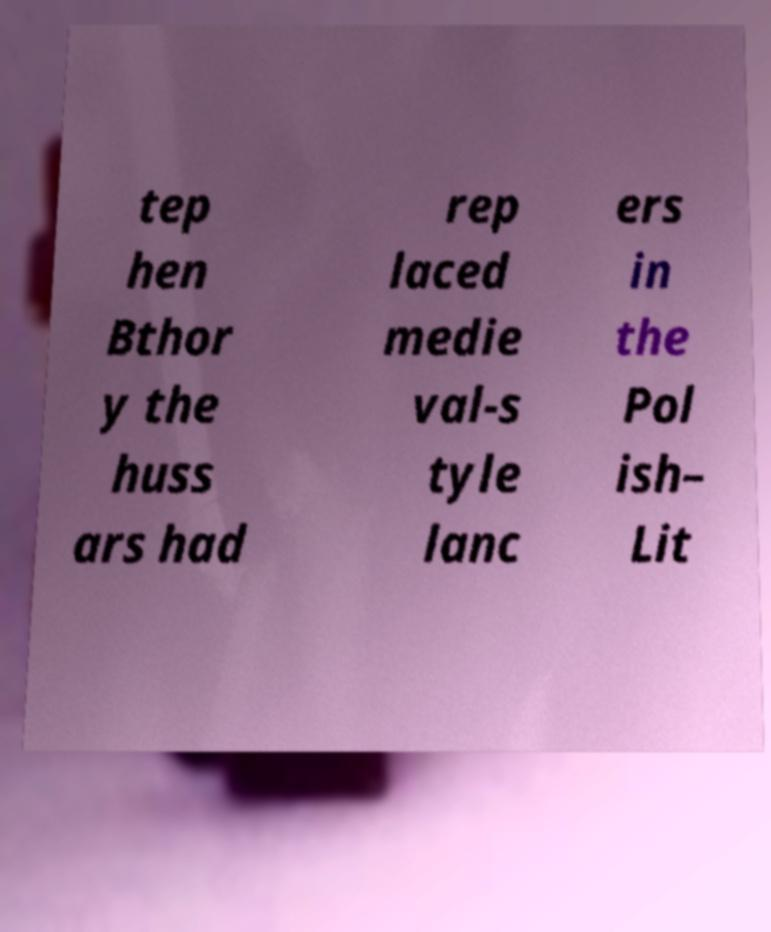I need the written content from this picture converted into text. Can you do that? tep hen Bthor y the huss ars had rep laced medie val-s tyle lanc ers in the Pol ish– Lit 